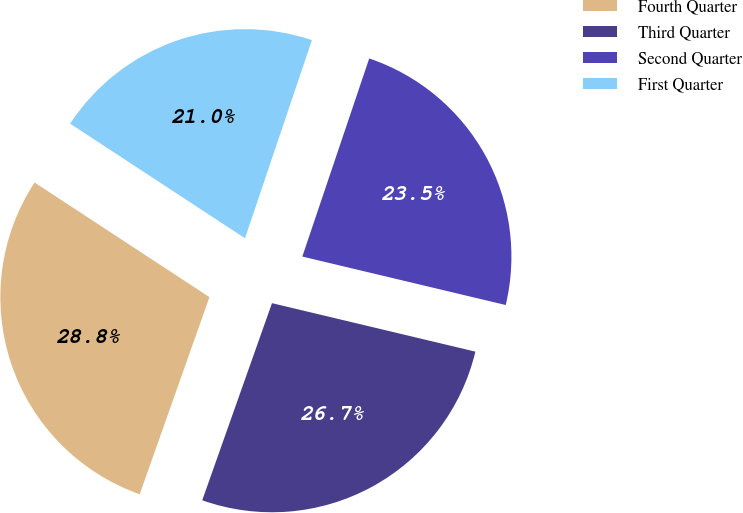<chart> <loc_0><loc_0><loc_500><loc_500><pie_chart><fcel>Fourth Quarter<fcel>Third Quarter<fcel>Second Quarter<fcel>First Quarter<nl><fcel>28.82%<fcel>26.69%<fcel>23.54%<fcel>20.95%<nl></chart> 